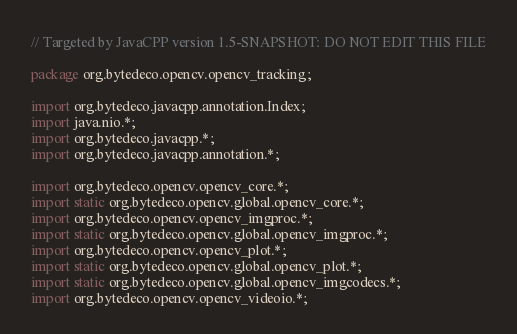Convert code to text. <code><loc_0><loc_0><loc_500><loc_500><_Java_>// Targeted by JavaCPP version 1.5-SNAPSHOT: DO NOT EDIT THIS FILE

package org.bytedeco.opencv.opencv_tracking;

import org.bytedeco.javacpp.annotation.Index;
import java.nio.*;
import org.bytedeco.javacpp.*;
import org.bytedeco.javacpp.annotation.*;

import org.bytedeco.opencv.opencv_core.*;
import static org.bytedeco.opencv.global.opencv_core.*;
import org.bytedeco.opencv.opencv_imgproc.*;
import static org.bytedeco.opencv.global.opencv_imgproc.*;
import org.bytedeco.opencv.opencv_plot.*;
import static org.bytedeco.opencv.global.opencv_plot.*;
import static org.bytedeco.opencv.global.opencv_imgcodecs.*;
import org.bytedeco.opencv.opencv_videoio.*;</code> 